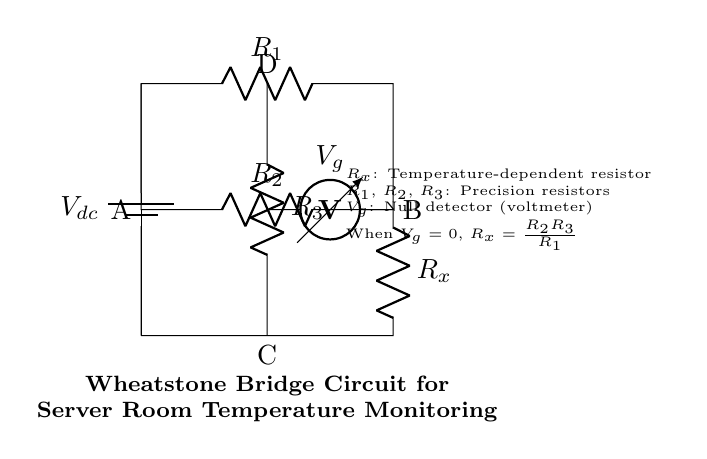What component is used to measure voltage in the circuit? The voltmeter labeled as V_g serves to measure the voltage difference across the bridge.
Answer: voltmeter What does the term R_x represent in this circuit? The term R_x denotes a temperature-dependent resistor, which changes its resistance based on temperature variations.
Answer: temperature-dependent resistor What equation is used to determine R_x when V_g is zero? When V_g equals zero, the relationship is R_x = (R_2 * R_3) / R_1, showing how the resistances relate to one another in the bridge configuration for balance.
Answer: R_x = (R_2 * R_3) / R_1 How many precision resistors are shown in this Wheatstone bridge? The circuit includes three precision resistors labeled R_1, R_2, and R_3.
Answer: three What role does the battery play in this Wheatstone bridge circuit? The battery provides a constant DC voltage, allowing for the establishment of voltage across the bridge and enabling the measurement of resistance.
Answer: provides DC voltage What happens when the voltmeter reads zero? A zero reading on the voltmeter indicates that the bridge is balanced, meaning R_x equals (R_2 * R_3) / R_1, allowing for precise resistance measurement.
Answer: bridge is balanced 